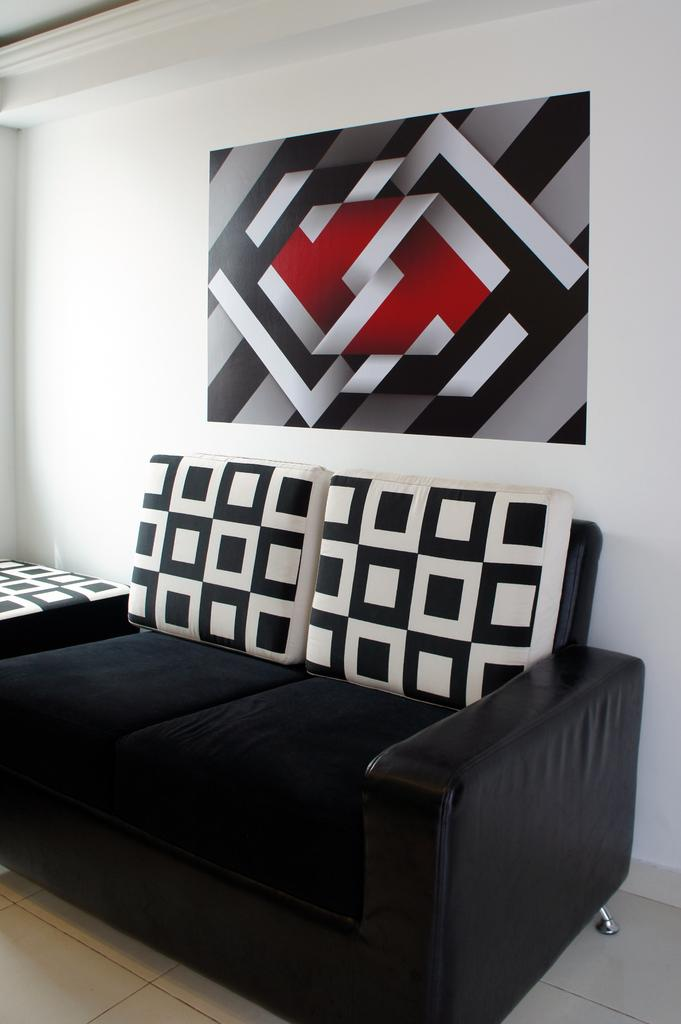What color is the sofa in the room? The sofa in the room is black. What can be seen on the sofa? The sofa has white pillows. What is behind the sofa in the room? There is a wall behind the sofa. What is on the wall behind the sofa? There is a painting on the wall. Can you hear the quince laughing in the room? There is no quince or laughter present in the room; the image only shows a black sofa with white pillows, a wall, and a painting on the wall. 